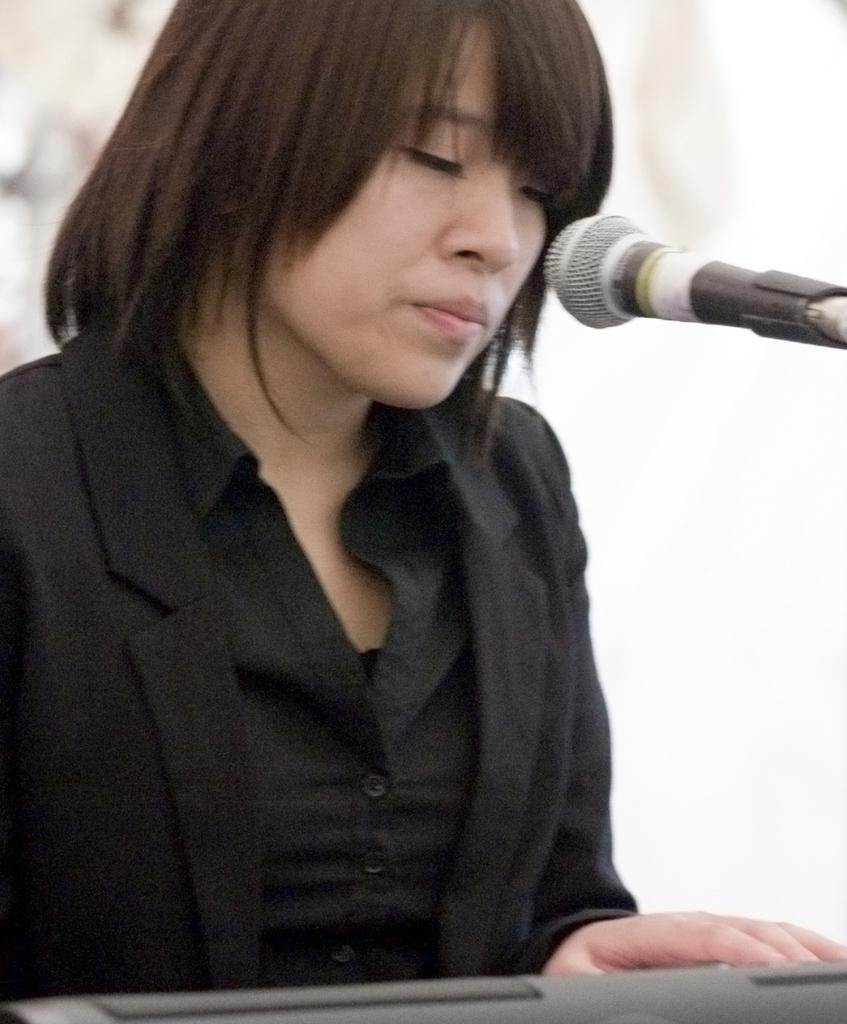Who is the main subject in the image? There is a lady in the image. What is the lady wearing? The lady is wearing a black dress. What object can be seen near the lady? There is a mic in the image. What is the color of the background in the image? The background of the image is white in color. What scientific discovery was made by the lady in the image? There is no indication of a scientific discovery in the image; it simply shows a lady wearing a black dress and standing near a mic. 